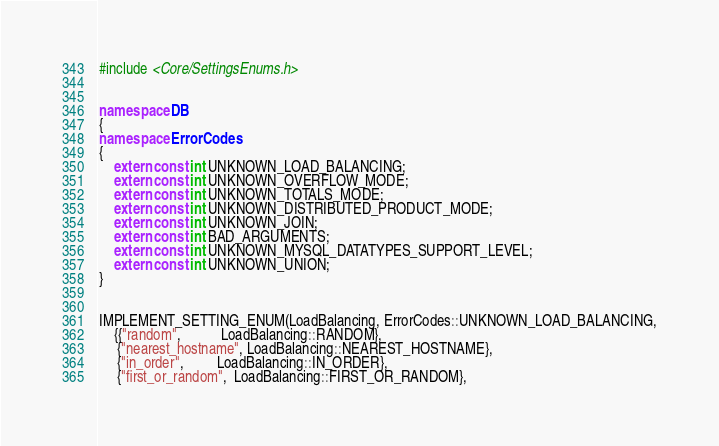Convert code to text. <code><loc_0><loc_0><loc_500><loc_500><_C++_>#include <Core/SettingsEnums.h>


namespace DB
{
namespace ErrorCodes
{
    extern const int UNKNOWN_LOAD_BALANCING;
    extern const int UNKNOWN_OVERFLOW_MODE;
    extern const int UNKNOWN_TOTALS_MODE;
    extern const int UNKNOWN_DISTRIBUTED_PRODUCT_MODE;
    extern const int UNKNOWN_JOIN;
    extern const int BAD_ARGUMENTS;
    extern const int UNKNOWN_MYSQL_DATATYPES_SUPPORT_LEVEL;
    extern const int UNKNOWN_UNION;
}


IMPLEMENT_SETTING_ENUM(LoadBalancing, ErrorCodes::UNKNOWN_LOAD_BALANCING,
    {{"random",           LoadBalancing::RANDOM},
     {"nearest_hostname", LoadBalancing::NEAREST_HOSTNAME},
     {"in_order",         LoadBalancing::IN_ORDER},
     {"first_or_random",  LoadBalancing::FIRST_OR_RANDOM},</code> 